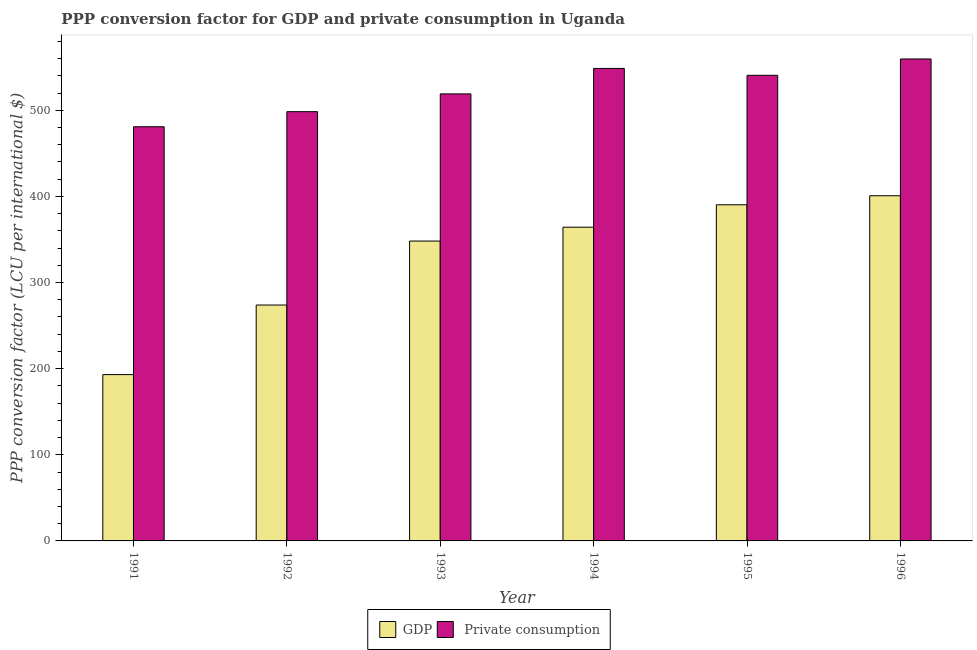How many bars are there on the 4th tick from the left?
Your answer should be compact. 2. What is the ppp conversion factor for gdp in 1995?
Provide a short and direct response. 390.23. Across all years, what is the maximum ppp conversion factor for gdp?
Make the answer very short. 400.75. Across all years, what is the minimum ppp conversion factor for gdp?
Offer a very short reply. 193.09. What is the total ppp conversion factor for gdp in the graph?
Offer a very short reply. 1970.28. What is the difference between the ppp conversion factor for private consumption in 1992 and that in 1995?
Offer a very short reply. -42.19. What is the difference between the ppp conversion factor for gdp in 1996 and the ppp conversion factor for private consumption in 1992?
Keep it short and to the point. 126.88. What is the average ppp conversion factor for gdp per year?
Offer a very short reply. 328.38. In the year 1994, what is the difference between the ppp conversion factor for gdp and ppp conversion factor for private consumption?
Your response must be concise. 0. What is the ratio of the ppp conversion factor for gdp in 1991 to that in 1996?
Make the answer very short. 0.48. What is the difference between the highest and the second highest ppp conversion factor for gdp?
Offer a terse response. 10.53. What is the difference between the highest and the lowest ppp conversion factor for gdp?
Make the answer very short. 207.66. Is the sum of the ppp conversion factor for private consumption in 1991 and 1994 greater than the maximum ppp conversion factor for gdp across all years?
Make the answer very short. Yes. What does the 2nd bar from the left in 1994 represents?
Make the answer very short.  Private consumption. What does the 1st bar from the right in 1994 represents?
Give a very brief answer.  Private consumption. How are the legend labels stacked?
Provide a succinct answer. Horizontal. What is the title of the graph?
Ensure brevity in your answer.  PPP conversion factor for GDP and private consumption in Uganda. Does "Underweight" appear as one of the legend labels in the graph?
Provide a succinct answer. No. What is the label or title of the X-axis?
Make the answer very short. Year. What is the label or title of the Y-axis?
Provide a succinct answer. PPP conversion factor (LCU per international $). What is the PPP conversion factor (LCU per international $) of GDP in 1991?
Your answer should be very brief. 193.09. What is the PPP conversion factor (LCU per international $) in  Private consumption in 1991?
Your answer should be very brief. 480.83. What is the PPP conversion factor (LCU per international $) of GDP in 1992?
Offer a terse response. 273.87. What is the PPP conversion factor (LCU per international $) of  Private consumption in 1992?
Your answer should be very brief. 498.34. What is the PPP conversion factor (LCU per international $) in GDP in 1993?
Offer a very short reply. 348.12. What is the PPP conversion factor (LCU per international $) of  Private consumption in 1993?
Your answer should be very brief. 518.97. What is the PPP conversion factor (LCU per international $) of GDP in 1994?
Give a very brief answer. 364.21. What is the PPP conversion factor (LCU per international $) in  Private consumption in 1994?
Offer a terse response. 548.54. What is the PPP conversion factor (LCU per international $) in GDP in 1995?
Offer a very short reply. 390.23. What is the PPP conversion factor (LCU per international $) in  Private consumption in 1995?
Your answer should be compact. 540.53. What is the PPP conversion factor (LCU per international $) of GDP in 1996?
Make the answer very short. 400.75. What is the PPP conversion factor (LCU per international $) in  Private consumption in 1996?
Offer a very short reply. 559.52. Across all years, what is the maximum PPP conversion factor (LCU per international $) of GDP?
Provide a short and direct response. 400.75. Across all years, what is the maximum PPP conversion factor (LCU per international $) in  Private consumption?
Ensure brevity in your answer.  559.52. Across all years, what is the minimum PPP conversion factor (LCU per international $) in GDP?
Ensure brevity in your answer.  193.09. Across all years, what is the minimum PPP conversion factor (LCU per international $) in  Private consumption?
Give a very brief answer. 480.83. What is the total PPP conversion factor (LCU per international $) in GDP in the graph?
Your answer should be very brief. 1970.28. What is the total PPP conversion factor (LCU per international $) of  Private consumption in the graph?
Provide a succinct answer. 3146.74. What is the difference between the PPP conversion factor (LCU per international $) of GDP in 1991 and that in 1992?
Offer a terse response. -80.78. What is the difference between the PPP conversion factor (LCU per international $) in  Private consumption in 1991 and that in 1992?
Make the answer very short. -17.51. What is the difference between the PPP conversion factor (LCU per international $) of GDP in 1991 and that in 1993?
Give a very brief answer. -155.03. What is the difference between the PPP conversion factor (LCU per international $) in  Private consumption in 1991 and that in 1993?
Ensure brevity in your answer.  -38.14. What is the difference between the PPP conversion factor (LCU per international $) in GDP in 1991 and that in 1994?
Keep it short and to the point. -171.12. What is the difference between the PPP conversion factor (LCU per international $) of  Private consumption in 1991 and that in 1994?
Your response must be concise. -67.71. What is the difference between the PPP conversion factor (LCU per international $) in GDP in 1991 and that in 1995?
Your answer should be very brief. -197.13. What is the difference between the PPP conversion factor (LCU per international $) in  Private consumption in 1991 and that in 1995?
Your response must be concise. -59.7. What is the difference between the PPP conversion factor (LCU per international $) of GDP in 1991 and that in 1996?
Make the answer very short. -207.66. What is the difference between the PPP conversion factor (LCU per international $) in  Private consumption in 1991 and that in 1996?
Your response must be concise. -78.69. What is the difference between the PPP conversion factor (LCU per international $) in GDP in 1992 and that in 1993?
Make the answer very short. -74.25. What is the difference between the PPP conversion factor (LCU per international $) of  Private consumption in 1992 and that in 1993?
Give a very brief answer. -20.63. What is the difference between the PPP conversion factor (LCU per international $) of GDP in 1992 and that in 1994?
Make the answer very short. -90.34. What is the difference between the PPP conversion factor (LCU per international $) of  Private consumption in 1992 and that in 1994?
Provide a succinct answer. -50.2. What is the difference between the PPP conversion factor (LCU per international $) in GDP in 1992 and that in 1995?
Your answer should be compact. -116.36. What is the difference between the PPP conversion factor (LCU per international $) in  Private consumption in 1992 and that in 1995?
Ensure brevity in your answer.  -42.19. What is the difference between the PPP conversion factor (LCU per international $) of GDP in 1992 and that in 1996?
Offer a very short reply. -126.88. What is the difference between the PPP conversion factor (LCU per international $) in  Private consumption in 1992 and that in 1996?
Your response must be concise. -61.17. What is the difference between the PPP conversion factor (LCU per international $) of GDP in 1993 and that in 1994?
Your answer should be very brief. -16.09. What is the difference between the PPP conversion factor (LCU per international $) in  Private consumption in 1993 and that in 1994?
Offer a very short reply. -29.57. What is the difference between the PPP conversion factor (LCU per international $) in GDP in 1993 and that in 1995?
Your response must be concise. -42.1. What is the difference between the PPP conversion factor (LCU per international $) of  Private consumption in 1993 and that in 1995?
Your answer should be very brief. -21.56. What is the difference between the PPP conversion factor (LCU per international $) of GDP in 1993 and that in 1996?
Give a very brief answer. -52.63. What is the difference between the PPP conversion factor (LCU per international $) in  Private consumption in 1993 and that in 1996?
Your response must be concise. -40.54. What is the difference between the PPP conversion factor (LCU per international $) of GDP in 1994 and that in 1995?
Give a very brief answer. -26.01. What is the difference between the PPP conversion factor (LCU per international $) of  Private consumption in 1994 and that in 1995?
Offer a very short reply. 8.01. What is the difference between the PPP conversion factor (LCU per international $) of GDP in 1994 and that in 1996?
Offer a very short reply. -36.54. What is the difference between the PPP conversion factor (LCU per international $) of  Private consumption in 1994 and that in 1996?
Offer a very short reply. -10.97. What is the difference between the PPP conversion factor (LCU per international $) of GDP in 1995 and that in 1996?
Offer a terse response. -10.53. What is the difference between the PPP conversion factor (LCU per international $) in  Private consumption in 1995 and that in 1996?
Offer a very short reply. -18.99. What is the difference between the PPP conversion factor (LCU per international $) of GDP in 1991 and the PPP conversion factor (LCU per international $) of  Private consumption in 1992?
Give a very brief answer. -305.25. What is the difference between the PPP conversion factor (LCU per international $) of GDP in 1991 and the PPP conversion factor (LCU per international $) of  Private consumption in 1993?
Your answer should be compact. -325.88. What is the difference between the PPP conversion factor (LCU per international $) of GDP in 1991 and the PPP conversion factor (LCU per international $) of  Private consumption in 1994?
Offer a very short reply. -355.45. What is the difference between the PPP conversion factor (LCU per international $) of GDP in 1991 and the PPP conversion factor (LCU per international $) of  Private consumption in 1995?
Provide a short and direct response. -347.44. What is the difference between the PPP conversion factor (LCU per international $) in GDP in 1991 and the PPP conversion factor (LCU per international $) in  Private consumption in 1996?
Offer a very short reply. -366.43. What is the difference between the PPP conversion factor (LCU per international $) in GDP in 1992 and the PPP conversion factor (LCU per international $) in  Private consumption in 1993?
Provide a short and direct response. -245.1. What is the difference between the PPP conversion factor (LCU per international $) in GDP in 1992 and the PPP conversion factor (LCU per international $) in  Private consumption in 1994?
Give a very brief answer. -274.67. What is the difference between the PPP conversion factor (LCU per international $) of GDP in 1992 and the PPP conversion factor (LCU per international $) of  Private consumption in 1995?
Offer a very short reply. -266.66. What is the difference between the PPP conversion factor (LCU per international $) of GDP in 1992 and the PPP conversion factor (LCU per international $) of  Private consumption in 1996?
Ensure brevity in your answer.  -285.65. What is the difference between the PPP conversion factor (LCU per international $) of GDP in 1993 and the PPP conversion factor (LCU per international $) of  Private consumption in 1994?
Make the answer very short. -200.42. What is the difference between the PPP conversion factor (LCU per international $) in GDP in 1993 and the PPP conversion factor (LCU per international $) in  Private consumption in 1995?
Your answer should be very brief. -192.41. What is the difference between the PPP conversion factor (LCU per international $) of GDP in 1993 and the PPP conversion factor (LCU per international $) of  Private consumption in 1996?
Your answer should be compact. -211.39. What is the difference between the PPP conversion factor (LCU per international $) of GDP in 1994 and the PPP conversion factor (LCU per international $) of  Private consumption in 1995?
Offer a very short reply. -176.32. What is the difference between the PPP conversion factor (LCU per international $) in GDP in 1994 and the PPP conversion factor (LCU per international $) in  Private consumption in 1996?
Your answer should be compact. -195.3. What is the difference between the PPP conversion factor (LCU per international $) of GDP in 1995 and the PPP conversion factor (LCU per international $) of  Private consumption in 1996?
Give a very brief answer. -169.29. What is the average PPP conversion factor (LCU per international $) in GDP per year?
Your answer should be compact. 328.38. What is the average PPP conversion factor (LCU per international $) in  Private consumption per year?
Offer a terse response. 524.46. In the year 1991, what is the difference between the PPP conversion factor (LCU per international $) in GDP and PPP conversion factor (LCU per international $) in  Private consumption?
Make the answer very short. -287.74. In the year 1992, what is the difference between the PPP conversion factor (LCU per international $) in GDP and PPP conversion factor (LCU per international $) in  Private consumption?
Offer a terse response. -224.47. In the year 1993, what is the difference between the PPP conversion factor (LCU per international $) in GDP and PPP conversion factor (LCU per international $) in  Private consumption?
Your answer should be very brief. -170.85. In the year 1994, what is the difference between the PPP conversion factor (LCU per international $) in GDP and PPP conversion factor (LCU per international $) in  Private consumption?
Keep it short and to the point. -184.33. In the year 1995, what is the difference between the PPP conversion factor (LCU per international $) of GDP and PPP conversion factor (LCU per international $) of  Private consumption?
Provide a short and direct response. -150.3. In the year 1996, what is the difference between the PPP conversion factor (LCU per international $) of GDP and PPP conversion factor (LCU per international $) of  Private consumption?
Provide a short and direct response. -158.76. What is the ratio of the PPP conversion factor (LCU per international $) of GDP in 1991 to that in 1992?
Your answer should be compact. 0.7. What is the ratio of the PPP conversion factor (LCU per international $) of  Private consumption in 1991 to that in 1992?
Provide a short and direct response. 0.96. What is the ratio of the PPP conversion factor (LCU per international $) of GDP in 1991 to that in 1993?
Provide a short and direct response. 0.55. What is the ratio of the PPP conversion factor (LCU per international $) in  Private consumption in 1991 to that in 1993?
Provide a succinct answer. 0.93. What is the ratio of the PPP conversion factor (LCU per international $) in GDP in 1991 to that in 1994?
Provide a short and direct response. 0.53. What is the ratio of the PPP conversion factor (LCU per international $) in  Private consumption in 1991 to that in 1994?
Provide a short and direct response. 0.88. What is the ratio of the PPP conversion factor (LCU per international $) of GDP in 1991 to that in 1995?
Make the answer very short. 0.49. What is the ratio of the PPP conversion factor (LCU per international $) of  Private consumption in 1991 to that in 1995?
Give a very brief answer. 0.89. What is the ratio of the PPP conversion factor (LCU per international $) in GDP in 1991 to that in 1996?
Your response must be concise. 0.48. What is the ratio of the PPP conversion factor (LCU per international $) of  Private consumption in 1991 to that in 1996?
Make the answer very short. 0.86. What is the ratio of the PPP conversion factor (LCU per international $) of GDP in 1992 to that in 1993?
Your answer should be very brief. 0.79. What is the ratio of the PPP conversion factor (LCU per international $) in  Private consumption in 1992 to that in 1993?
Give a very brief answer. 0.96. What is the ratio of the PPP conversion factor (LCU per international $) of GDP in 1992 to that in 1994?
Your answer should be very brief. 0.75. What is the ratio of the PPP conversion factor (LCU per international $) in  Private consumption in 1992 to that in 1994?
Ensure brevity in your answer.  0.91. What is the ratio of the PPP conversion factor (LCU per international $) of GDP in 1992 to that in 1995?
Your answer should be compact. 0.7. What is the ratio of the PPP conversion factor (LCU per international $) in  Private consumption in 1992 to that in 1995?
Keep it short and to the point. 0.92. What is the ratio of the PPP conversion factor (LCU per international $) of GDP in 1992 to that in 1996?
Make the answer very short. 0.68. What is the ratio of the PPP conversion factor (LCU per international $) of  Private consumption in 1992 to that in 1996?
Your answer should be compact. 0.89. What is the ratio of the PPP conversion factor (LCU per international $) of GDP in 1993 to that in 1994?
Your answer should be compact. 0.96. What is the ratio of the PPP conversion factor (LCU per international $) in  Private consumption in 1993 to that in 1994?
Your answer should be compact. 0.95. What is the ratio of the PPP conversion factor (LCU per international $) in GDP in 1993 to that in 1995?
Offer a terse response. 0.89. What is the ratio of the PPP conversion factor (LCU per international $) in  Private consumption in 1993 to that in 1995?
Ensure brevity in your answer.  0.96. What is the ratio of the PPP conversion factor (LCU per international $) in GDP in 1993 to that in 1996?
Make the answer very short. 0.87. What is the ratio of the PPP conversion factor (LCU per international $) in  Private consumption in 1993 to that in 1996?
Ensure brevity in your answer.  0.93. What is the ratio of the PPP conversion factor (LCU per international $) in GDP in 1994 to that in 1995?
Offer a terse response. 0.93. What is the ratio of the PPP conversion factor (LCU per international $) in  Private consumption in 1994 to that in 1995?
Provide a succinct answer. 1.01. What is the ratio of the PPP conversion factor (LCU per international $) of GDP in 1994 to that in 1996?
Make the answer very short. 0.91. What is the ratio of the PPP conversion factor (LCU per international $) in  Private consumption in 1994 to that in 1996?
Provide a succinct answer. 0.98. What is the ratio of the PPP conversion factor (LCU per international $) of GDP in 1995 to that in 1996?
Provide a succinct answer. 0.97. What is the ratio of the PPP conversion factor (LCU per international $) of  Private consumption in 1995 to that in 1996?
Give a very brief answer. 0.97. What is the difference between the highest and the second highest PPP conversion factor (LCU per international $) of GDP?
Give a very brief answer. 10.53. What is the difference between the highest and the second highest PPP conversion factor (LCU per international $) in  Private consumption?
Keep it short and to the point. 10.97. What is the difference between the highest and the lowest PPP conversion factor (LCU per international $) in GDP?
Give a very brief answer. 207.66. What is the difference between the highest and the lowest PPP conversion factor (LCU per international $) in  Private consumption?
Offer a very short reply. 78.69. 